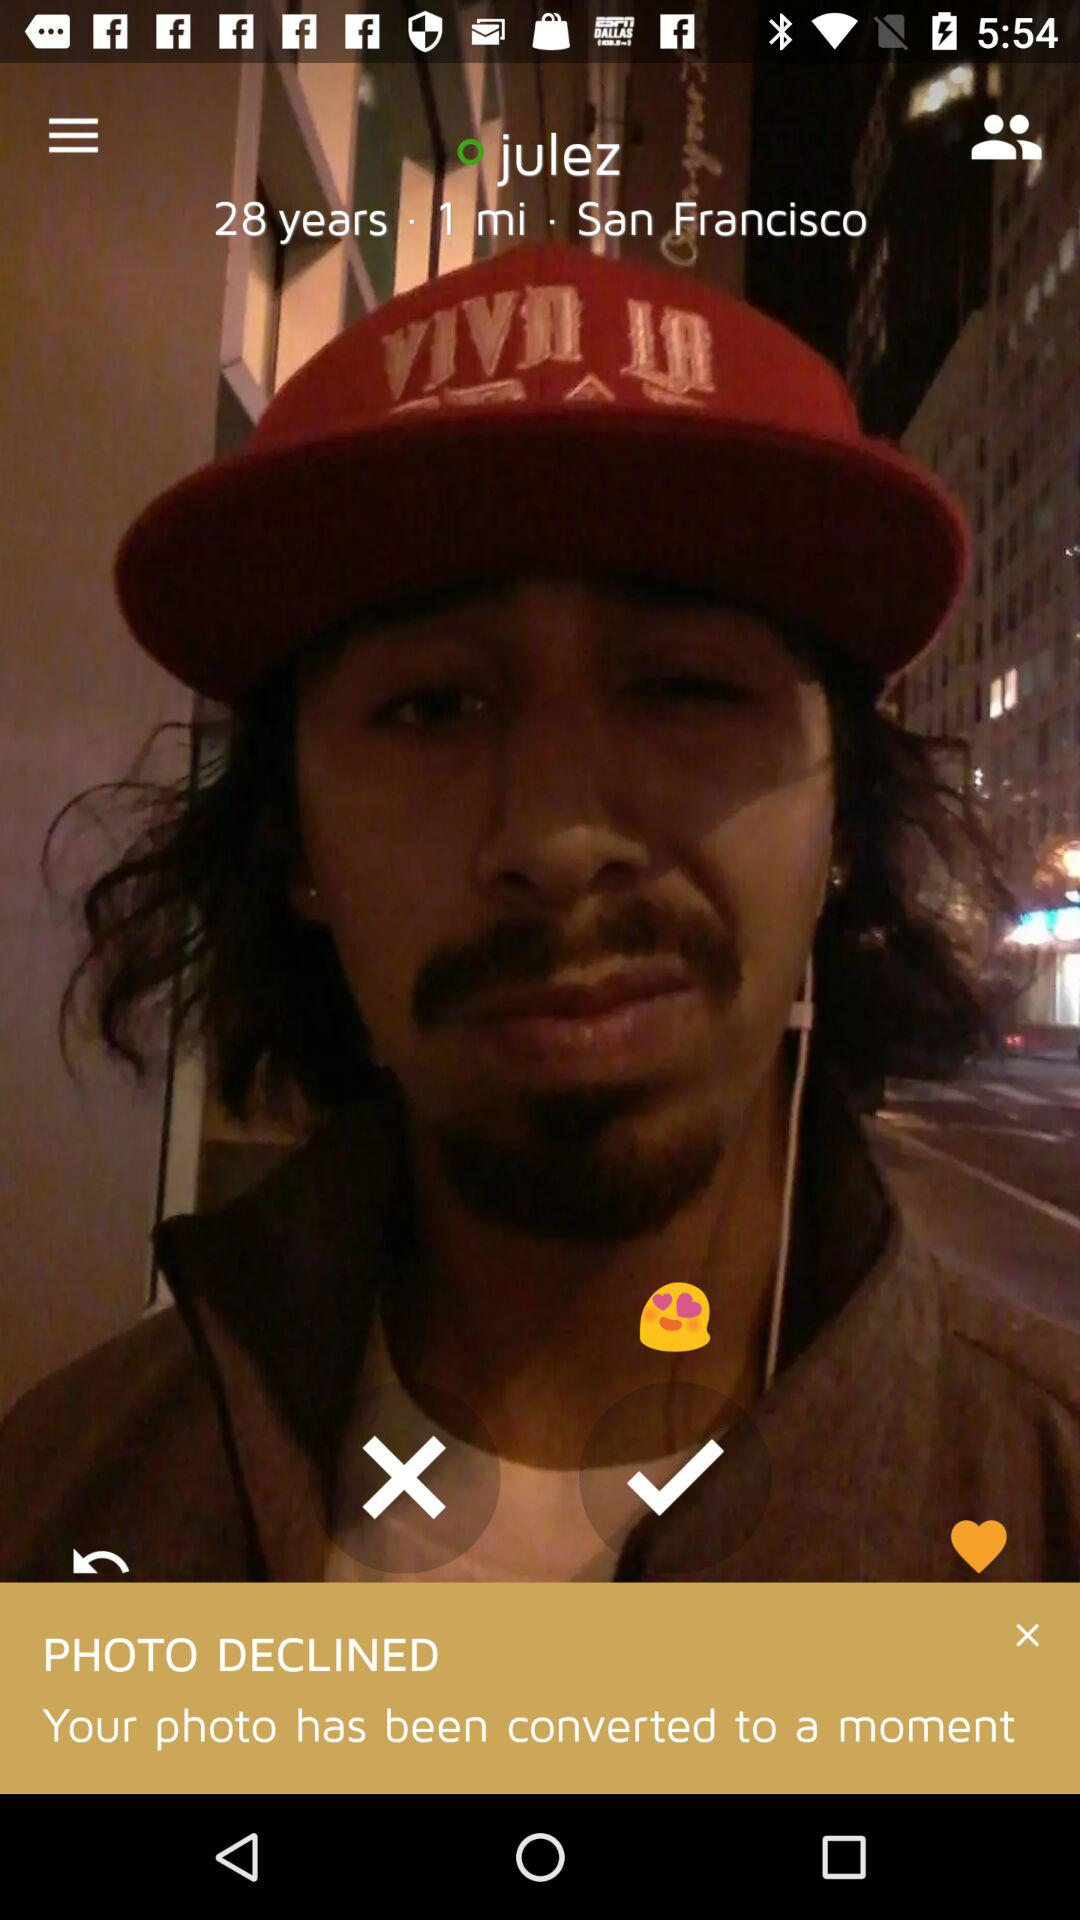What is the age of the person? The person is 28 years old. 